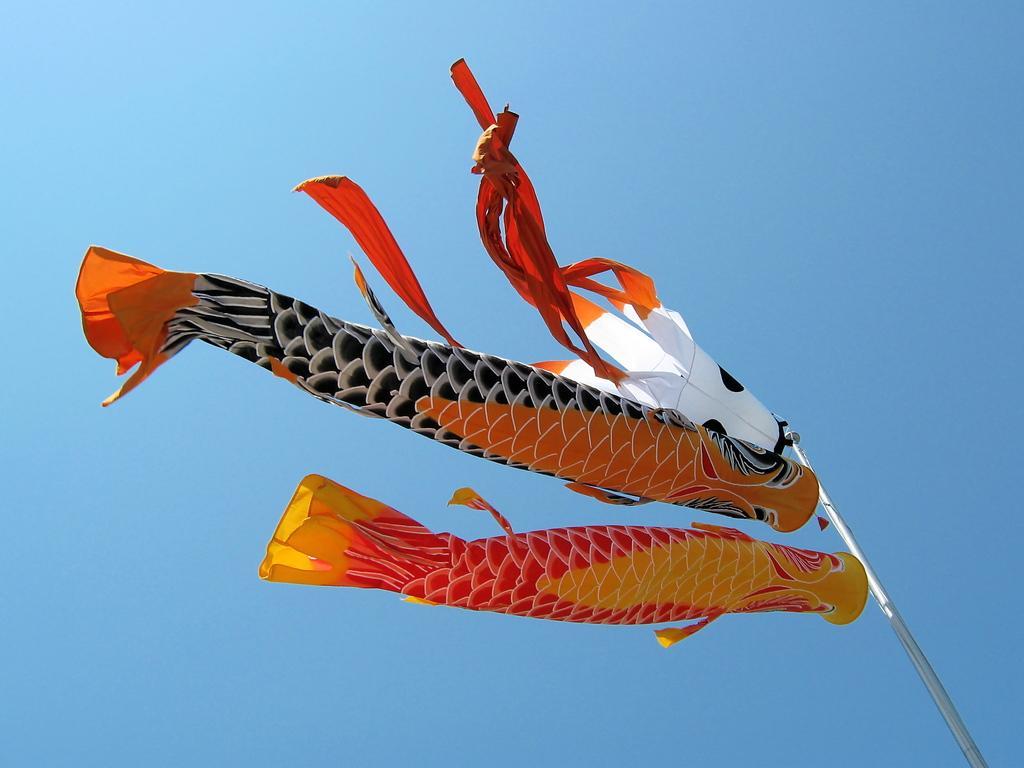Please provide a concise description of this image. In this image I can see in the middle there are fish type things that are flying in the air, this is the sky. 